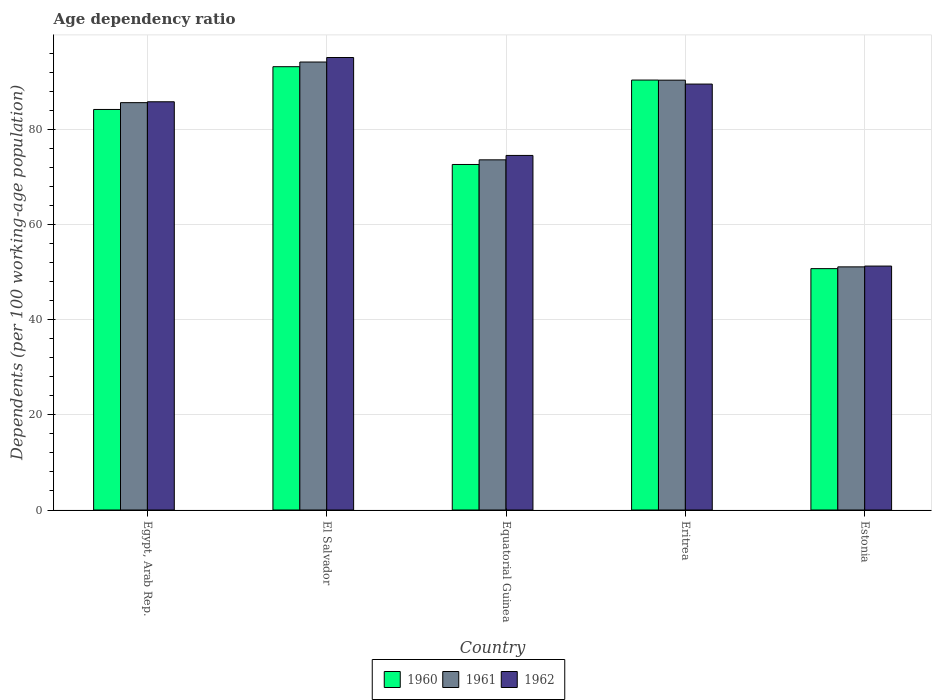How many different coloured bars are there?
Ensure brevity in your answer.  3. How many bars are there on the 4th tick from the left?
Offer a very short reply. 3. What is the label of the 3rd group of bars from the left?
Your answer should be compact. Equatorial Guinea. What is the age dependency ratio in in 1962 in Eritrea?
Keep it short and to the point. 89.48. Across all countries, what is the maximum age dependency ratio in in 1962?
Provide a short and direct response. 95.06. Across all countries, what is the minimum age dependency ratio in in 1962?
Make the answer very short. 51.25. In which country was the age dependency ratio in in 1962 maximum?
Your answer should be very brief. El Salvador. In which country was the age dependency ratio in in 1961 minimum?
Offer a very short reply. Estonia. What is the total age dependency ratio in in 1960 in the graph?
Make the answer very short. 390.9. What is the difference between the age dependency ratio in in 1962 in El Salvador and that in Estonia?
Offer a terse response. 43.82. What is the difference between the age dependency ratio in in 1960 in Eritrea and the age dependency ratio in in 1961 in El Salvador?
Offer a very short reply. -3.79. What is the average age dependency ratio in in 1962 per country?
Make the answer very short. 79.21. What is the difference between the age dependency ratio in of/in 1961 and age dependency ratio in of/in 1962 in Estonia?
Give a very brief answer. -0.17. In how many countries, is the age dependency ratio in in 1962 greater than 88 %?
Your response must be concise. 2. What is the ratio of the age dependency ratio in in 1962 in El Salvador to that in Estonia?
Offer a very short reply. 1.86. Is the difference between the age dependency ratio in in 1961 in El Salvador and Eritrea greater than the difference between the age dependency ratio in in 1962 in El Salvador and Eritrea?
Your response must be concise. No. What is the difference between the highest and the second highest age dependency ratio in in 1960?
Your answer should be compact. 6.18. What is the difference between the highest and the lowest age dependency ratio in in 1960?
Provide a short and direct response. 42.42. What does the 1st bar from the left in El Salvador represents?
Provide a short and direct response. 1960. How many countries are there in the graph?
Offer a terse response. 5. Are the values on the major ticks of Y-axis written in scientific E-notation?
Keep it short and to the point. No. How are the legend labels stacked?
Provide a succinct answer. Horizontal. What is the title of the graph?
Give a very brief answer. Age dependency ratio. Does "1994" appear as one of the legend labels in the graph?
Your response must be concise. No. What is the label or title of the X-axis?
Provide a short and direct response. Country. What is the label or title of the Y-axis?
Your response must be concise. Dependents (per 100 working-age population). What is the Dependents (per 100 working-age population) of 1960 in Egypt, Arab Rep.?
Offer a terse response. 84.15. What is the Dependents (per 100 working-age population) in 1961 in Egypt, Arab Rep.?
Give a very brief answer. 85.58. What is the Dependents (per 100 working-age population) in 1962 in Egypt, Arab Rep.?
Offer a very short reply. 85.76. What is the Dependents (per 100 working-age population) of 1960 in El Salvador?
Keep it short and to the point. 93.13. What is the Dependents (per 100 working-age population) in 1961 in El Salvador?
Keep it short and to the point. 94.11. What is the Dependents (per 100 working-age population) in 1962 in El Salvador?
Provide a short and direct response. 95.06. What is the Dependents (per 100 working-age population) of 1960 in Equatorial Guinea?
Provide a succinct answer. 72.59. What is the Dependents (per 100 working-age population) of 1961 in Equatorial Guinea?
Provide a short and direct response. 73.56. What is the Dependents (per 100 working-age population) in 1962 in Equatorial Guinea?
Offer a very short reply. 74.49. What is the Dependents (per 100 working-age population) in 1960 in Eritrea?
Offer a terse response. 90.33. What is the Dependents (per 100 working-age population) in 1961 in Eritrea?
Your response must be concise. 90.3. What is the Dependents (per 100 working-age population) of 1962 in Eritrea?
Offer a terse response. 89.48. What is the Dependents (per 100 working-age population) of 1960 in Estonia?
Make the answer very short. 50.71. What is the Dependents (per 100 working-age population) of 1961 in Estonia?
Offer a terse response. 51.08. What is the Dependents (per 100 working-age population) in 1962 in Estonia?
Make the answer very short. 51.25. Across all countries, what is the maximum Dependents (per 100 working-age population) in 1960?
Keep it short and to the point. 93.13. Across all countries, what is the maximum Dependents (per 100 working-age population) of 1961?
Give a very brief answer. 94.11. Across all countries, what is the maximum Dependents (per 100 working-age population) in 1962?
Offer a terse response. 95.06. Across all countries, what is the minimum Dependents (per 100 working-age population) of 1960?
Ensure brevity in your answer.  50.71. Across all countries, what is the minimum Dependents (per 100 working-age population) of 1961?
Your response must be concise. 51.08. Across all countries, what is the minimum Dependents (per 100 working-age population) in 1962?
Your answer should be very brief. 51.25. What is the total Dependents (per 100 working-age population) of 1960 in the graph?
Provide a succinct answer. 390.9. What is the total Dependents (per 100 working-age population) of 1961 in the graph?
Ensure brevity in your answer.  394.63. What is the total Dependents (per 100 working-age population) in 1962 in the graph?
Give a very brief answer. 396.04. What is the difference between the Dependents (per 100 working-age population) in 1960 in Egypt, Arab Rep. and that in El Salvador?
Provide a succinct answer. -8.99. What is the difference between the Dependents (per 100 working-age population) in 1961 in Egypt, Arab Rep. and that in El Salvador?
Make the answer very short. -8.53. What is the difference between the Dependents (per 100 working-age population) of 1962 in Egypt, Arab Rep. and that in El Salvador?
Offer a very short reply. -9.3. What is the difference between the Dependents (per 100 working-age population) in 1960 in Egypt, Arab Rep. and that in Equatorial Guinea?
Your answer should be compact. 11.56. What is the difference between the Dependents (per 100 working-age population) of 1961 in Egypt, Arab Rep. and that in Equatorial Guinea?
Provide a succinct answer. 12.02. What is the difference between the Dependents (per 100 working-age population) of 1962 in Egypt, Arab Rep. and that in Equatorial Guinea?
Provide a succinct answer. 11.27. What is the difference between the Dependents (per 100 working-age population) in 1960 in Egypt, Arab Rep. and that in Eritrea?
Provide a succinct answer. -6.18. What is the difference between the Dependents (per 100 working-age population) of 1961 in Egypt, Arab Rep. and that in Eritrea?
Offer a very short reply. -4.72. What is the difference between the Dependents (per 100 working-age population) in 1962 in Egypt, Arab Rep. and that in Eritrea?
Keep it short and to the point. -3.72. What is the difference between the Dependents (per 100 working-age population) in 1960 in Egypt, Arab Rep. and that in Estonia?
Provide a succinct answer. 33.44. What is the difference between the Dependents (per 100 working-age population) of 1961 in Egypt, Arab Rep. and that in Estonia?
Give a very brief answer. 34.5. What is the difference between the Dependents (per 100 working-age population) of 1962 in Egypt, Arab Rep. and that in Estonia?
Make the answer very short. 34.52. What is the difference between the Dependents (per 100 working-age population) in 1960 in El Salvador and that in Equatorial Guinea?
Keep it short and to the point. 20.54. What is the difference between the Dependents (per 100 working-age population) in 1961 in El Salvador and that in Equatorial Guinea?
Offer a very short reply. 20.55. What is the difference between the Dependents (per 100 working-age population) of 1962 in El Salvador and that in Equatorial Guinea?
Your answer should be very brief. 20.57. What is the difference between the Dependents (per 100 working-age population) of 1960 in El Salvador and that in Eritrea?
Give a very brief answer. 2.81. What is the difference between the Dependents (per 100 working-age population) in 1961 in El Salvador and that in Eritrea?
Provide a succinct answer. 3.81. What is the difference between the Dependents (per 100 working-age population) in 1962 in El Salvador and that in Eritrea?
Offer a terse response. 5.58. What is the difference between the Dependents (per 100 working-age population) of 1960 in El Salvador and that in Estonia?
Your answer should be very brief. 42.42. What is the difference between the Dependents (per 100 working-age population) of 1961 in El Salvador and that in Estonia?
Offer a terse response. 43.03. What is the difference between the Dependents (per 100 working-age population) of 1962 in El Salvador and that in Estonia?
Provide a short and direct response. 43.82. What is the difference between the Dependents (per 100 working-age population) in 1960 in Equatorial Guinea and that in Eritrea?
Ensure brevity in your answer.  -17.74. What is the difference between the Dependents (per 100 working-age population) of 1961 in Equatorial Guinea and that in Eritrea?
Provide a succinct answer. -16.74. What is the difference between the Dependents (per 100 working-age population) of 1962 in Equatorial Guinea and that in Eritrea?
Give a very brief answer. -14.99. What is the difference between the Dependents (per 100 working-age population) of 1960 in Equatorial Guinea and that in Estonia?
Ensure brevity in your answer.  21.88. What is the difference between the Dependents (per 100 working-age population) of 1961 in Equatorial Guinea and that in Estonia?
Make the answer very short. 22.48. What is the difference between the Dependents (per 100 working-age population) in 1962 in Equatorial Guinea and that in Estonia?
Keep it short and to the point. 23.24. What is the difference between the Dependents (per 100 working-age population) of 1960 in Eritrea and that in Estonia?
Provide a short and direct response. 39.62. What is the difference between the Dependents (per 100 working-age population) of 1961 in Eritrea and that in Estonia?
Give a very brief answer. 39.22. What is the difference between the Dependents (per 100 working-age population) of 1962 in Eritrea and that in Estonia?
Provide a succinct answer. 38.23. What is the difference between the Dependents (per 100 working-age population) of 1960 in Egypt, Arab Rep. and the Dependents (per 100 working-age population) of 1961 in El Salvador?
Offer a terse response. -9.97. What is the difference between the Dependents (per 100 working-age population) of 1960 in Egypt, Arab Rep. and the Dependents (per 100 working-age population) of 1962 in El Salvador?
Your answer should be compact. -10.92. What is the difference between the Dependents (per 100 working-age population) of 1961 in Egypt, Arab Rep. and the Dependents (per 100 working-age population) of 1962 in El Salvador?
Offer a very short reply. -9.48. What is the difference between the Dependents (per 100 working-age population) in 1960 in Egypt, Arab Rep. and the Dependents (per 100 working-age population) in 1961 in Equatorial Guinea?
Make the answer very short. 10.58. What is the difference between the Dependents (per 100 working-age population) of 1960 in Egypt, Arab Rep. and the Dependents (per 100 working-age population) of 1962 in Equatorial Guinea?
Your response must be concise. 9.65. What is the difference between the Dependents (per 100 working-age population) in 1961 in Egypt, Arab Rep. and the Dependents (per 100 working-age population) in 1962 in Equatorial Guinea?
Make the answer very short. 11.09. What is the difference between the Dependents (per 100 working-age population) in 1960 in Egypt, Arab Rep. and the Dependents (per 100 working-age population) in 1961 in Eritrea?
Your response must be concise. -6.16. What is the difference between the Dependents (per 100 working-age population) of 1960 in Egypt, Arab Rep. and the Dependents (per 100 working-age population) of 1962 in Eritrea?
Make the answer very short. -5.33. What is the difference between the Dependents (per 100 working-age population) of 1961 in Egypt, Arab Rep. and the Dependents (per 100 working-age population) of 1962 in Eritrea?
Give a very brief answer. -3.9. What is the difference between the Dependents (per 100 working-age population) of 1960 in Egypt, Arab Rep. and the Dependents (per 100 working-age population) of 1961 in Estonia?
Your answer should be very brief. 33.07. What is the difference between the Dependents (per 100 working-age population) in 1960 in Egypt, Arab Rep. and the Dependents (per 100 working-age population) in 1962 in Estonia?
Make the answer very short. 32.9. What is the difference between the Dependents (per 100 working-age population) of 1961 in Egypt, Arab Rep. and the Dependents (per 100 working-age population) of 1962 in Estonia?
Your answer should be compact. 34.33. What is the difference between the Dependents (per 100 working-age population) of 1960 in El Salvador and the Dependents (per 100 working-age population) of 1961 in Equatorial Guinea?
Keep it short and to the point. 19.57. What is the difference between the Dependents (per 100 working-age population) of 1960 in El Salvador and the Dependents (per 100 working-age population) of 1962 in Equatorial Guinea?
Provide a short and direct response. 18.64. What is the difference between the Dependents (per 100 working-age population) of 1961 in El Salvador and the Dependents (per 100 working-age population) of 1962 in Equatorial Guinea?
Keep it short and to the point. 19.62. What is the difference between the Dependents (per 100 working-age population) in 1960 in El Salvador and the Dependents (per 100 working-age population) in 1961 in Eritrea?
Ensure brevity in your answer.  2.83. What is the difference between the Dependents (per 100 working-age population) in 1960 in El Salvador and the Dependents (per 100 working-age population) in 1962 in Eritrea?
Make the answer very short. 3.65. What is the difference between the Dependents (per 100 working-age population) in 1961 in El Salvador and the Dependents (per 100 working-age population) in 1962 in Eritrea?
Keep it short and to the point. 4.63. What is the difference between the Dependents (per 100 working-age population) of 1960 in El Salvador and the Dependents (per 100 working-age population) of 1961 in Estonia?
Provide a short and direct response. 42.05. What is the difference between the Dependents (per 100 working-age population) in 1960 in El Salvador and the Dependents (per 100 working-age population) in 1962 in Estonia?
Your response must be concise. 41.88. What is the difference between the Dependents (per 100 working-age population) of 1961 in El Salvador and the Dependents (per 100 working-age population) of 1962 in Estonia?
Give a very brief answer. 42.87. What is the difference between the Dependents (per 100 working-age population) of 1960 in Equatorial Guinea and the Dependents (per 100 working-age population) of 1961 in Eritrea?
Your answer should be compact. -17.71. What is the difference between the Dependents (per 100 working-age population) in 1960 in Equatorial Guinea and the Dependents (per 100 working-age population) in 1962 in Eritrea?
Offer a very short reply. -16.89. What is the difference between the Dependents (per 100 working-age population) of 1961 in Equatorial Guinea and the Dependents (per 100 working-age population) of 1962 in Eritrea?
Provide a short and direct response. -15.92. What is the difference between the Dependents (per 100 working-age population) of 1960 in Equatorial Guinea and the Dependents (per 100 working-age population) of 1961 in Estonia?
Ensure brevity in your answer.  21.51. What is the difference between the Dependents (per 100 working-age population) in 1960 in Equatorial Guinea and the Dependents (per 100 working-age population) in 1962 in Estonia?
Ensure brevity in your answer.  21.34. What is the difference between the Dependents (per 100 working-age population) of 1961 in Equatorial Guinea and the Dependents (per 100 working-age population) of 1962 in Estonia?
Ensure brevity in your answer.  22.32. What is the difference between the Dependents (per 100 working-age population) in 1960 in Eritrea and the Dependents (per 100 working-age population) in 1961 in Estonia?
Give a very brief answer. 39.25. What is the difference between the Dependents (per 100 working-age population) in 1960 in Eritrea and the Dependents (per 100 working-age population) in 1962 in Estonia?
Give a very brief answer. 39.08. What is the difference between the Dependents (per 100 working-age population) in 1961 in Eritrea and the Dependents (per 100 working-age population) in 1962 in Estonia?
Give a very brief answer. 39.06. What is the average Dependents (per 100 working-age population) of 1960 per country?
Keep it short and to the point. 78.18. What is the average Dependents (per 100 working-age population) of 1961 per country?
Offer a terse response. 78.93. What is the average Dependents (per 100 working-age population) of 1962 per country?
Provide a short and direct response. 79.21. What is the difference between the Dependents (per 100 working-age population) in 1960 and Dependents (per 100 working-age population) in 1961 in Egypt, Arab Rep.?
Make the answer very short. -1.43. What is the difference between the Dependents (per 100 working-age population) of 1960 and Dependents (per 100 working-age population) of 1962 in Egypt, Arab Rep.?
Offer a terse response. -1.62. What is the difference between the Dependents (per 100 working-age population) in 1961 and Dependents (per 100 working-age population) in 1962 in Egypt, Arab Rep.?
Provide a short and direct response. -0.18. What is the difference between the Dependents (per 100 working-age population) of 1960 and Dependents (per 100 working-age population) of 1961 in El Salvador?
Keep it short and to the point. -0.98. What is the difference between the Dependents (per 100 working-age population) in 1960 and Dependents (per 100 working-age population) in 1962 in El Salvador?
Give a very brief answer. -1.93. What is the difference between the Dependents (per 100 working-age population) in 1961 and Dependents (per 100 working-age population) in 1962 in El Salvador?
Keep it short and to the point. -0.95. What is the difference between the Dependents (per 100 working-age population) of 1960 and Dependents (per 100 working-age population) of 1961 in Equatorial Guinea?
Your answer should be compact. -0.97. What is the difference between the Dependents (per 100 working-age population) in 1960 and Dependents (per 100 working-age population) in 1962 in Equatorial Guinea?
Keep it short and to the point. -1.9. What is the difference between the Dependents (per 100 working-age population) in 1961 and Dependents (per 100 working-age population) in 1962 in Equatorial Guinea?
Your answer should be very brief. -0.93. What is the difference between the Dependents (per 100 working-age population) in 1960 and Dependents (per 100 working-age population) in 1961 in Eritrea?
Provide a short and direct response. 0.02. What is the difference between the Dependents (per 100 working-age population) of 1960 and Dependents (per 100 working-age population) of 1962 in Eritrea?
Ensure brevity in your answer.  0.85. What is the difference between the Dependents (per 100 working-age population) in 1961 and Dependents (per 100 working-age population) in 1962 in Eritrea?
Provide a short and direct response. 0.82. What is the difference between the Dependents (per 100 working-age population) in 1960 and Dependents (per 100 working-age population) in 1961 in Estonia?
Give a very brief answer. -0.37. What is the difference between the Dependents (per 100 working-age population) in 1960 and Dependents (per 100 working-age population) in 1962 in Estonia?
Make the answer very short. -0.54. What is the difference between the Dependents (per 100 working-age population) of 1961 and Dependents (per 100 working-age population) of 1962 in Estonia?
Keep it short and to the point. -0.17. What is the ratio of the Dependents (per 100 working-age population) of 1960 in Egypt, Arab Rep. to that in El Salvador?
Your answer should be compact. 0.9. What is the ratio of the Dependents (per 100 working-age population) of 1961 in Egypt, Arab Rep. to that in El Salvador?
Your answer should be compact. 0.91. What is the ratio of the Dependents (per 100 working-age population) in 1962 in Egypt, Arab Rep. to that in El Salvador?
Provide a succinct answer. 0.9. What is the ratio of the Dependents (per 100 working-age population) in 1960 in Egypt, Arab Rep. to that in Equatorial Guinea?
Your answer should be compact. 1.16. What is the ratio of the Dependents (per 100 working-age population) in 1961 in Egypt, Arab Rep. to that in Equatorial Guinea?
Your response must be concise. 1.16. What is the ratio of the Dependents (per 100 working-age population) in 1962 in Egypt, Arab Rep. to that in Equatorial Guinea?
Offer a terse response. 1.15. What is the ratio of the Dependents (per 100 working-age population) in 1960 in Egypt, Arab Rep. to that in Eritrea?
Your response must be concise. 0.93. What is the ratio of the Dependents (per 100 working-age population) in 1961 in Egypt, Arab Rep. to that in Eritrea?
Ensure brevity in your answer.  0.95. What is the ratio of the Dependents (per 100 working-age population) in 1962 in Egypt, Arab Rep. to that in Eritrea?
Offer a terse response. 0.96. What is the ratio of the Dependents (per 100 working-age population) of 1960 in Egypt, Arab Rep. to that in Estonia?
Offer a terse response. 1.66. What is the ratio of the Dependents (per 100 working-age population) of 1961 in Egypt, Arab Rep. to that in Estonia?
Keep it short and to the point. 1.68. What is the ratio of the Dependents (per 100 working-age population) of 1962 in Egypt, Arab Rep. to that in Estonia?
Give a very brief answer. 1.67. What is the ratio of the Dependents (per 100 working-age population) in 1960 in El Salvador to that in Equatorial Guinea?
Your answer should be very brief. 1.28. What is the ratio of the Dependents (per 100 working-age population) of 1961 in El Salvador to that in Equatorial Guinea?
Ensure brevity in your answer.  1.28. What is the ratio of the Dependents (per 100 working-age population) of 1962 in El Salvador to that in Equatorial Guinea?
Make the answer very short. 1.28. What is the ratio of the Dependents (per 100 working-age population) in 1960 in El Salvador to that in Eritrea?
Your response must be concise. 1.03. What is the ratio of the Dependents (per 100 working-age population) in 1961 in El Salvador to that in Eritrea?
Make the answer very short. 1.04. What is the ratio of the Dependents (per 100 working-age population) in 1962 in El Salvador to that in Eritrea?
Ensure brevity in your answer.  1.06. What is the ratio of the Dependents (per 100 working-age population) of 1960 in El Salvador to that in Estonia?
Keep it short and to the point. 1.84. What is the ratio of the Dependents (per 100 working-age population) of 1961 in El Salvador to that in Estonia?
Keep it short and to the point. 1.84. What is the ratio of the Dependents (per 100 working-age population) of 1962 in El Salvador to that in Estonia?
Your response must be concise. 1.85. What is the ratio of the Dependents (per 100 working-age population) in 1960 in Equatorial Guinea to that in Eritrea?
Make the answer very short. 0.8. What is the ratio of the Dependents (per 100 working-age population) in 1961 in Equatorial Guinea to that in Eritrea?
Offer a terse response. 0.81. What is the ratio of the Dependents (per 100 working-age population) in 1962 in Equatorial Guinea to that in Eritrea?
Keep it short and to the point. 0.83. What is the ratio of the Dependents (per 100 working-age population) of 1960 in Equatorial Guinea to that in Estonia?
Your answer should be compact. 1.43. What is the ratio of the Dependents (per 100 working-age population) in 1961 in Equatorial Guinea to that in Estonia?
Make the answer very short. 1.44. What is the ratio of the Dependents (per 100 working-age population) of 1962 in Equatorial Guinea to that in Estonia?
Your answer should be very brief. 1.45. What is the ratio of the Dependents (per 100 working-age population) in 1960 in Eritrea to that in Estonia?
Give a very brief answer. 1.78. What is the ratio of the Dependents (per 100 working-age population) in 1961 in Eritrea to that in Estonia?
Your answer should be very brief. 1.77. What is the ratio of the Dependents (per 100 working-age population) in 1962 in Eritrea to that in Estonia?
Keep it short and to the point. 1.75. What is the difference between the highest and the second highest Dependents (per 100 working-age population) in 1960?
Ensure brevity in your answer.  2.81. What is the difference between the highest and the second highest Dependents (per 100 working-age population) of 1961?
Offer a terse response. 3.81. What is the difference between the highest and the second highest Dependents (per 100 working-age population) of 1962?
Provide a short and direct response. 5.58. What is the difference between the highest and the lowest Dependents (per 100 working-age population) in 1960?
Offer a terse response. 42.42. What is the difference between the highest and the lowest Dependents (per 100 working-age population) in 1961?
Provide a short and direct response. 43.03. What is the difference between the highest and the lowest Dependents (per 100 working-age population) in 1962?
Provide a short and direct response. 43.82. 